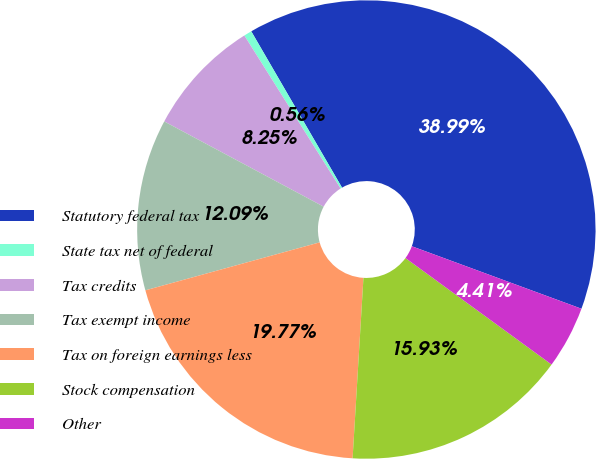<chart> <loc_0><loc_0><loc_500><loc_500><pie_chart><fcel>Statutory federal tax<fcel>State tax net of federal<fcel>Tax credits<fcel>Tax exempt income<fcel>Tax on foreign earnings less<fcel>Stock compensation<fcel>Other<nl><fcel>38.99%<fcel>0.56%<fcel>8.25%<fcel>12.09%<fcel>19.77%<fcel>15.93%<fcel>4.41%<nl></chart> 